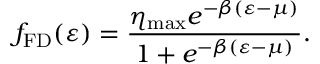<formula> <loc_0><loc_0><loc_500><loc_500>f _ { F D } ( \varepsilon ) = \frac { \eta _ { \max } e ^ { - \beta ( \varepsilon - \mu ) } } { 1 + e ^ { - \beta ( \varepsilon - \mu ) } } .</formula> 